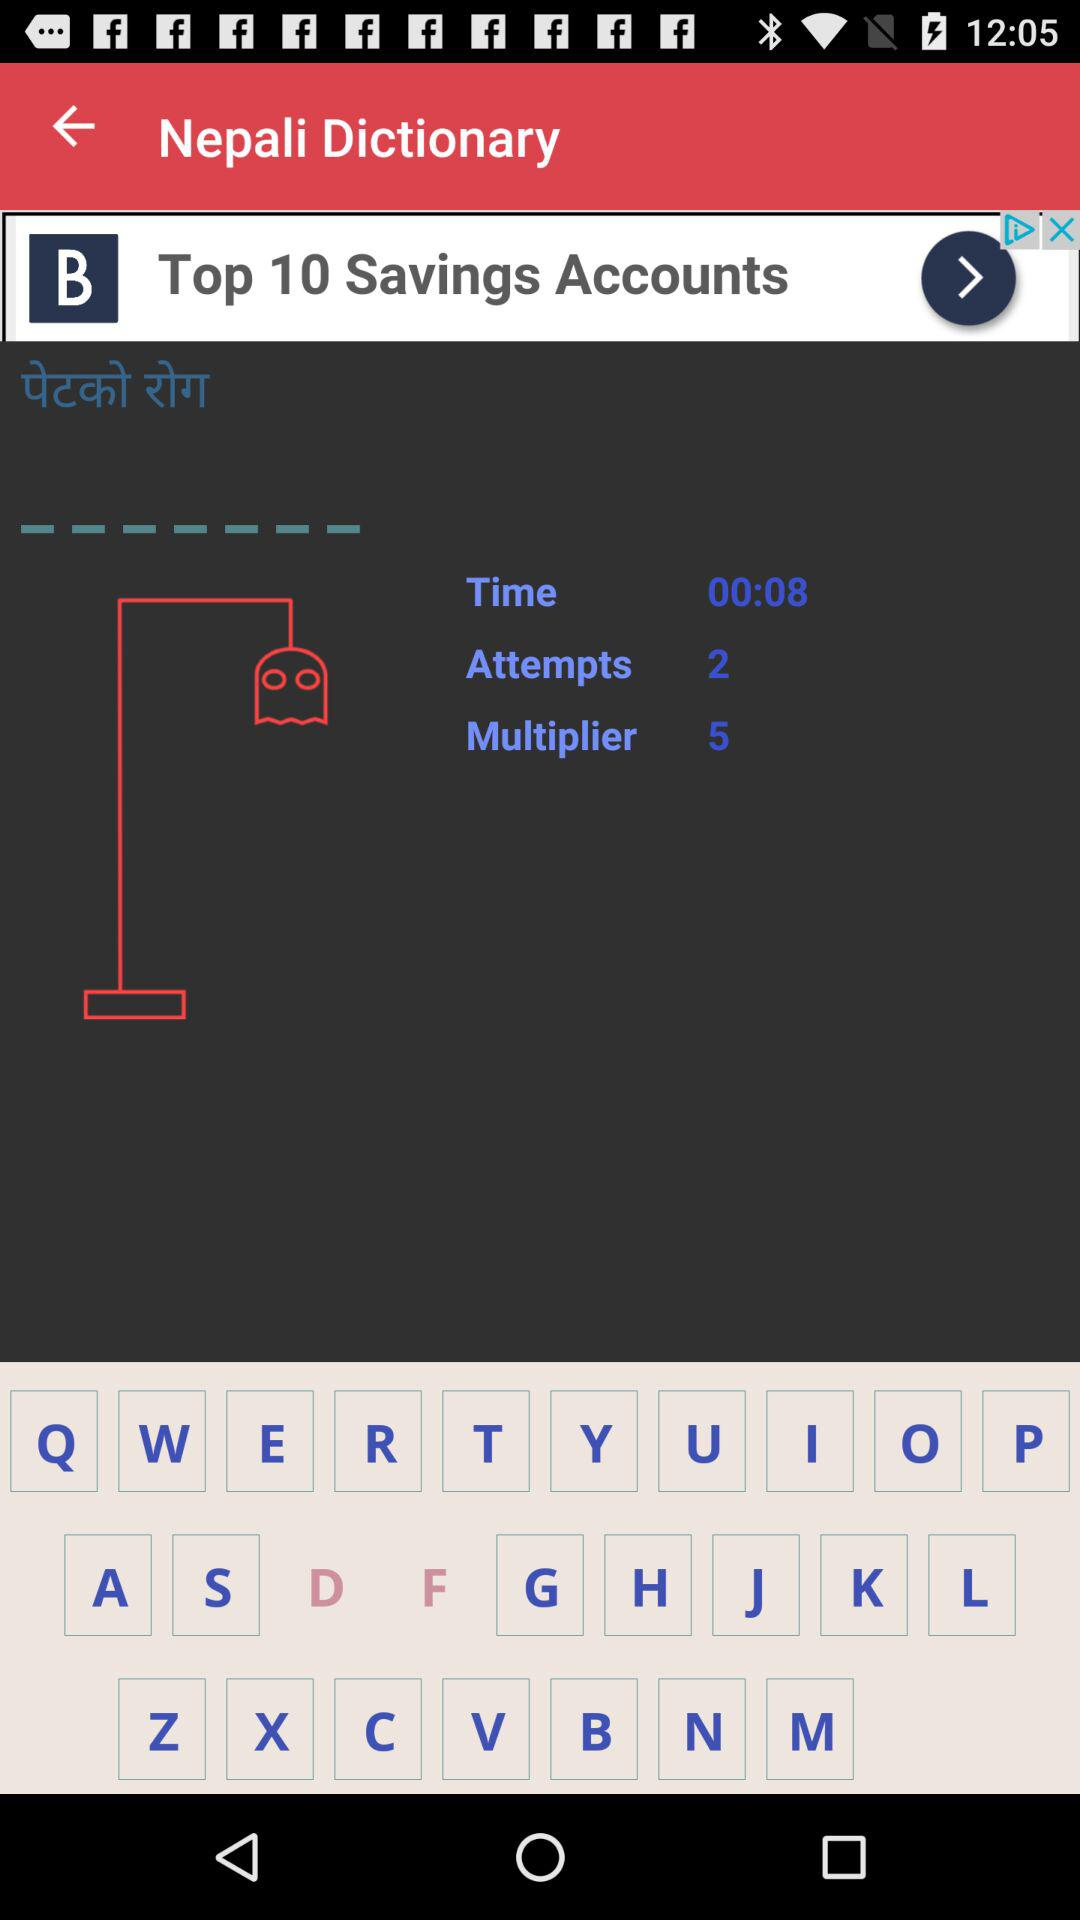How many attempts are given? There are 2 attempts given. 